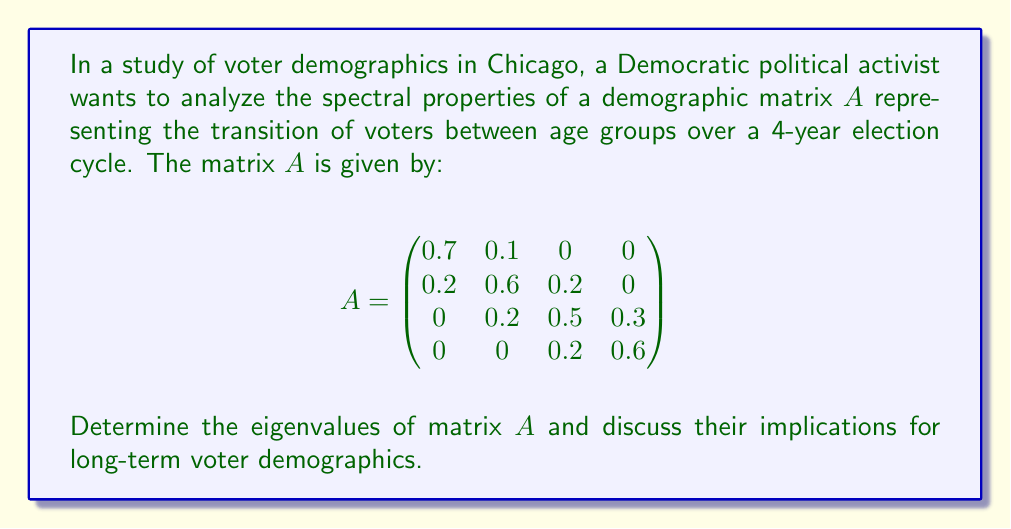Can you answer this question? To determine the eigenvalues of matrix $A$, we need to solve the characteristic equation:

$$\det(A - \lambda I) = 0$$

where $\lambda$ represents the eigenvalues and $I$ is the 4x4 identity matrix.

1) First, let's set up the matrix $A - \lambda I$:

$$A - \lambda I = \begin{pmatrix}
0.7-\lambda & 0.1 & 0 & 0 \\
0.2 & 0.6-\lambda & 0.2 & 0 \\
0 & 0.2 & 0.5-\lambda & 0.3 \\
0 & 0 & 0.2 & 0.6-\lambda
\end{pmatrix}$$

2) Now, we need to calculate the determinant of this matrix and set it to zero:

$$(0.7-\lambda)(0.6-\lambda)(0.5-\lambda)(0.6-\lambda) - 0.2^3(0.7-\lambda) - 0.1 \cdot 0.2^3 = 0$$

3) Expanding this equation:

$$\lambda^4 - 2.4\lambda^3 + 2.09\lambda^2 - 0.7868\lambda + 0.1008 = 0$$

4) This fourth-degree polynomial is difficult to solve by hand. Using numerical methods or a computer algebra system, we can find the roots of this equation, which are the eigenvalues:

$$\lambda_1 \approx 1.0000$$
$$\lambda_2 \approx 0.6124$$
$$\lambda_3 \approx 0.4438$$
$$\lambda_4 \approx 0.3438$$

5) Implications for long-term voter demographics:

- The largest eigenvalue ($\lambda_1 \approx 1$) is close to 1, which suggests that the overall voter population is relatively stable over time.
- The other eigenvalues are less than 1, indicating that certain demographic components will decrease over time.
- The second-largest eigenvalue ($\lambda_2 \approx 0.6124$) represents the slowest-decaying component, which may correspond to a specific age group that remains relatively stable.
- The smaller eigenvalues ($\lambda_3$ and $\lambda_4$) represent faster-decaying components, possibly indicating shifts in age distribution over time.

For the Democratic activist, this analysis suggests that while the overall voter base is stable, there may be shifts in age demographics that could affect voting patterns. Strategies may need to be adjusted to account for these changing demographics in future election cycles.
Answer: The eigenvalues of matrix $A$ are approximately:
$$\lambda_1 \approx 1.0000$$
$$\lambda_2 \approx 0.6124$$
$$\lambda_3 \approx 0.4438$$
$$\lambda_4 \approx 0.3438$$
These values indicate a stable overall voter population with some demographic shifts over time, potentially affecting future voting patterns. 